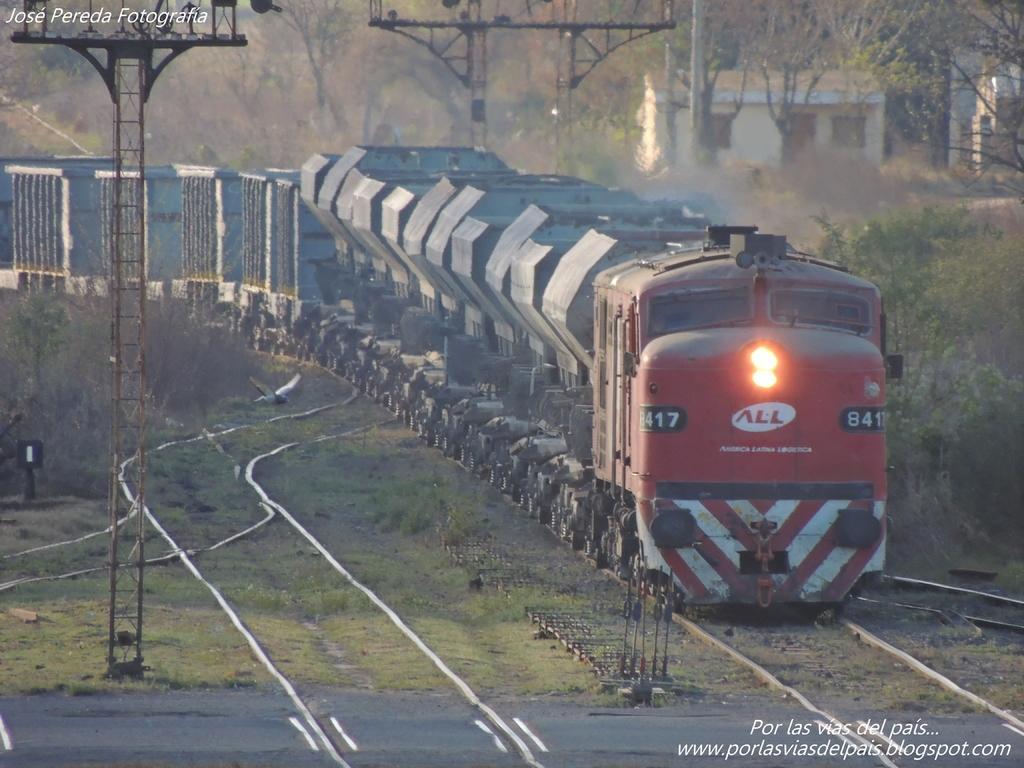Can you describe this image briefly? In this image there are tracks, on one track there is a train and there are iron poles, on the background there are trees, in the bottom right there is text, in the top left there is text. 